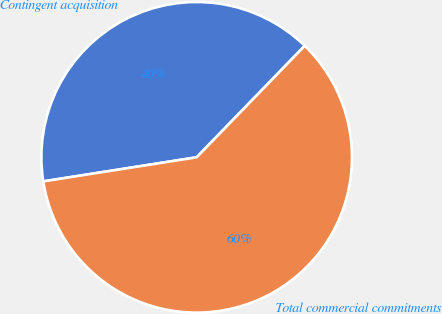Convert chart to OTSL. <chart><loc_0><loc_0><loc_500><loc_500><pie_chart><fcel>Contingent acquisition<fcel>Total commercial commitments<nl><fcel>39.73%<fcel>60.27%<nl></chart> 